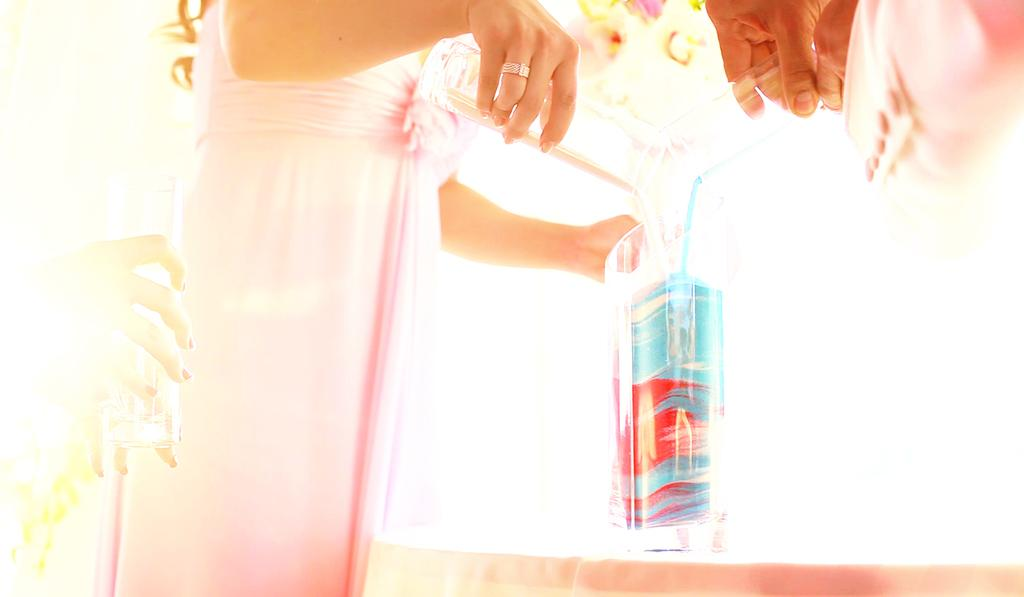How many people are in the image? There are two persons in the image. What are the persons holding in their hands? The persons are holding glass tumblers. What action are the persons performing in the image? The persons are pouring liquid into a container. What type of trucks can be seen in the image? There are no trucks present in the image. How does the pollution in the image affect the persons? There is no mention of pollution in the image, so it cannot be determined how it might affect the persons. 